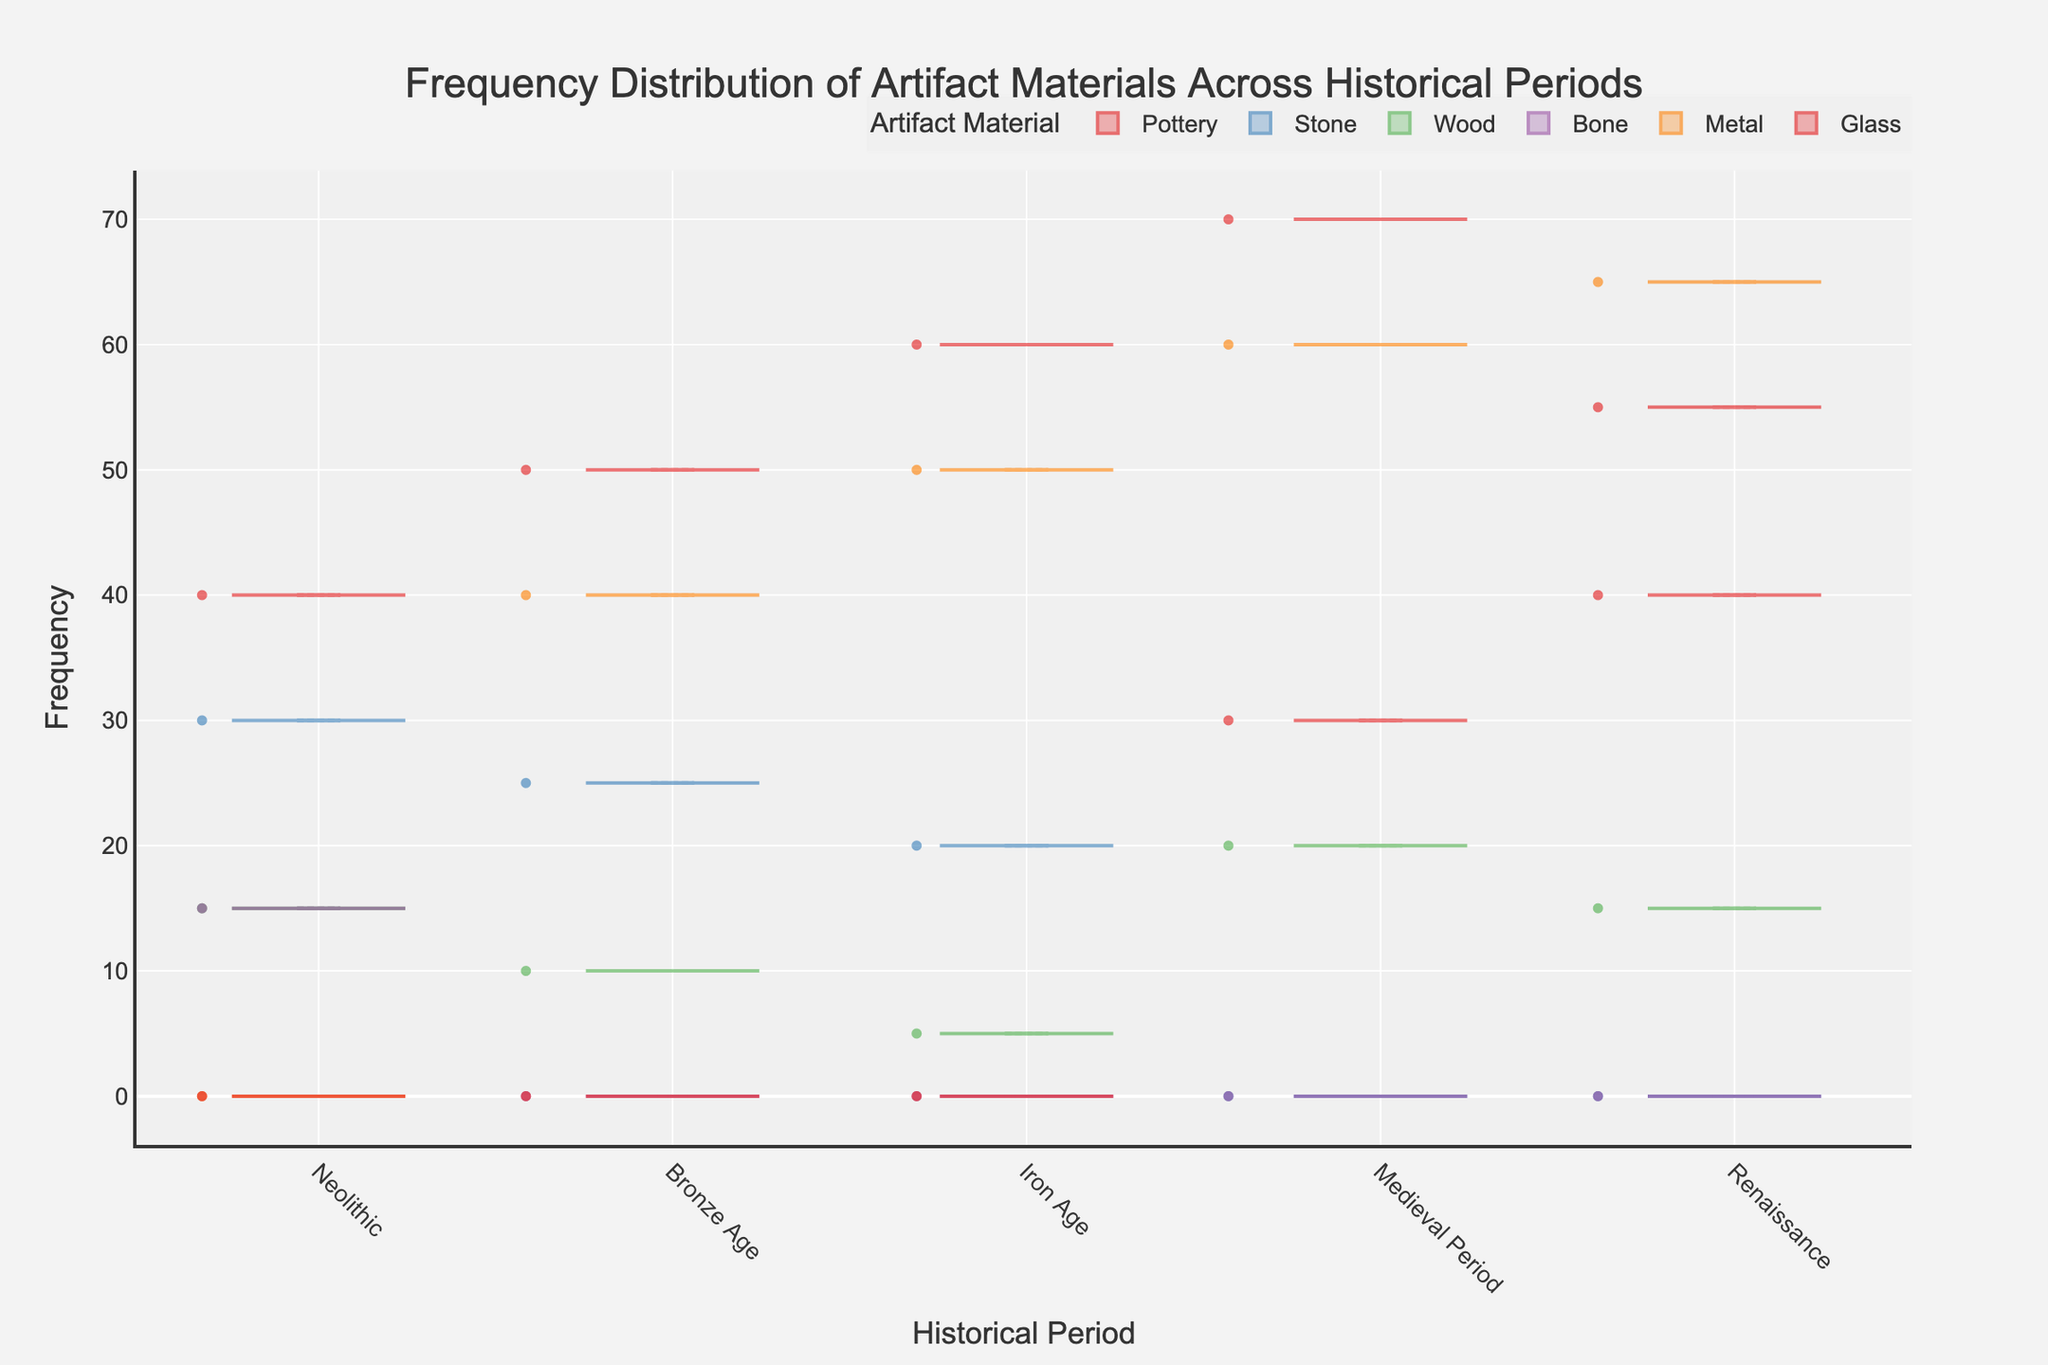What's the title of the plot? The title is displayed at the top of the figure. It provides a summary of what the plot is about.
Answer: Frequency Distribution of Artifact Materials Across Historical Periods What is the frequency of Metal artifacts in the Iron Age? Look at the Iron Age section of the plot and find the violin plot for Metal. The endpoint of the box indicates the value.
Answer: 50 Which historical period has the highest frequency of artifacts made of Glass? Compare the frequencies of the Glass material listed in the plot for each historical period to find the highest one.
Answer: Renaissance How many types of artifact materials are shown across the periods? The legend on the side shows the number of different artifact materials included in the plot.
Answer: 5 Which historical period has the lowest frequency of artifacts made from Wood? Compare the violin plots of Wood across different historical periods and find the one with the lowest point.
Answer: Iron Age What is the total frequency of Stone artifacts across all periods? Add the frequencies of Stone artifacts listed for each period: 30 (Neolithic) + 25 (Bronze Age) + 20 (Iron Age) + 0 (Medieval) + 0 (Renaissance).
Answer: 75 Which artifact material saw the most significant increase in frequency from the Neolithic to the Medieval Period? Compare the differences in frequency for each material from Neolithic (Pottery 40, Stone 30, Wood 15, Bone 15, Metal 0) to Medieval (Pottery 70, Stone 0, Wood 20, Bone 0, Metal 60). Pottery increases from 40 to 70, the highest increase.
Answer: Pottery How does the frequency of Pottery artifacts in the Neolithic period compare to the frequency of Pottery artifacts in the Renaissance? Look at the frequencies for Pottery in both periods: Neolithic has 40, Renaissance has 55.
Answer: Renaissance > Neolithic What is the average frequency of Metal artifacts across all periods with available data? Calculate the overall average frequency for periods including Metal: (40 (Bronze Age) + 50 (Iron Age) + 60 (Medieval) + 65 (Renaissance)) / 4 = 215 / 4.
Answer: 53.75 In which historical period is the frequency distribution of Wood artifacts the most spread out? Identify the period with the widest range (or largest variation) in the Wood artifact frequency distribution by looking at the violin plot's length.
Answer: Neolithic 